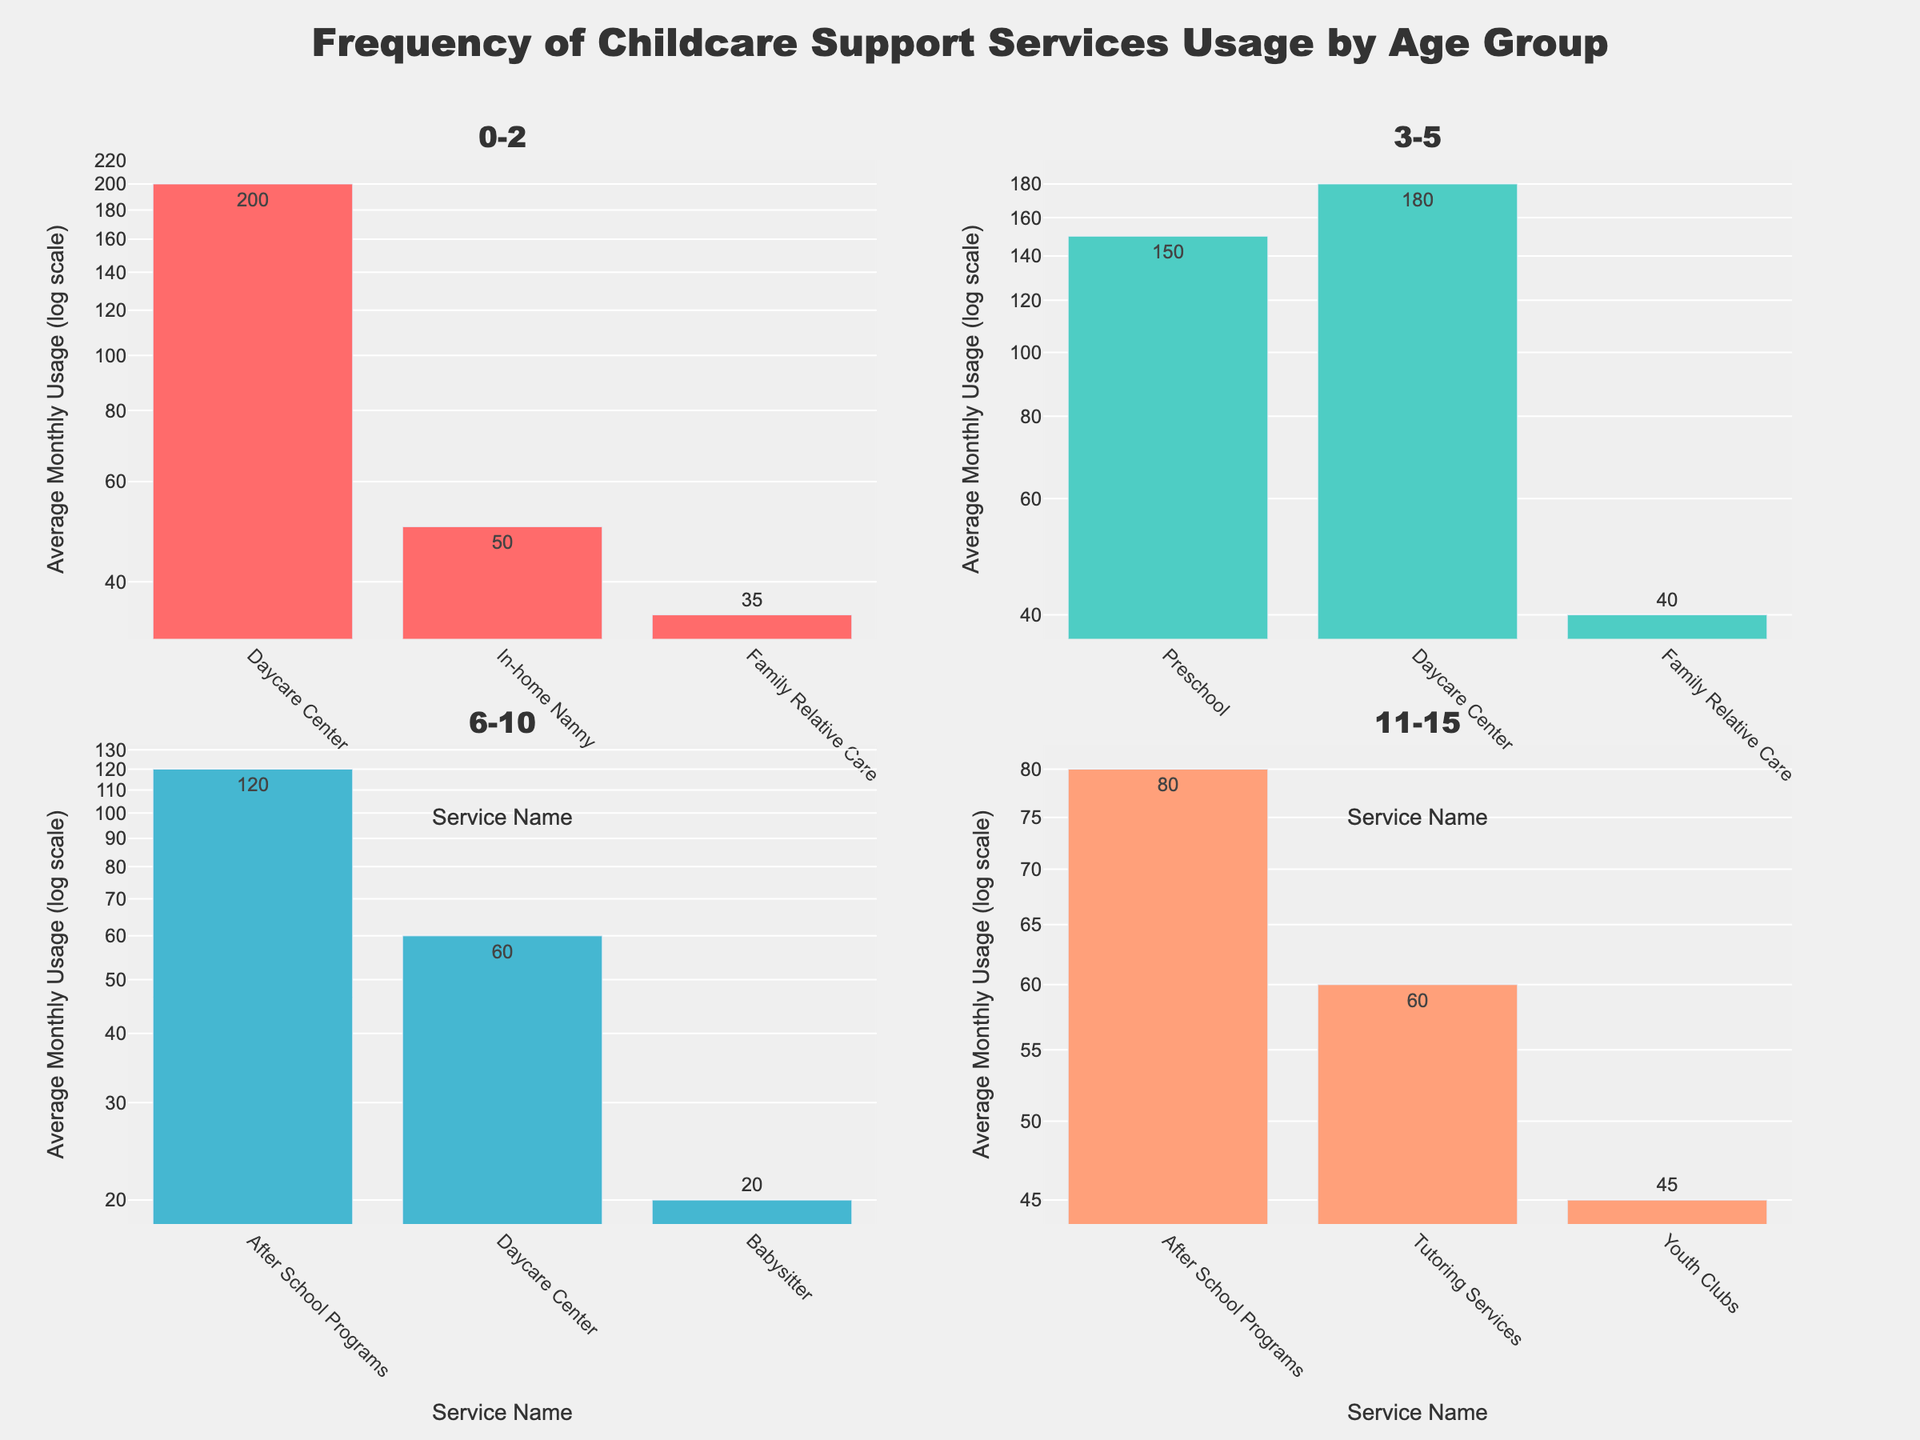Which age group has the highest average monthly usage for Daycare Center? By looking at the bar for Daycare Center in each subplot, the tallest bar appears in the 0-2 age group.
Answer: 0-2 Which childcare service has the lowest average monthly usage in the 6-10 age group? By observing the bars in the 6-10 age group subplot, the shortest bar is Babysitter.
Answer: Babysitter What is the combined average monthly usage for Family Relative Care across both the age groups it appears in? Family Relative Care usage appears in the 0-2 (35) and 3-5 (40) age groups. Adding them up: 35 + 40 = 75.
Answer: 75 How does the average monthly usage of Tutoring Services in the 11-15 age group compare to Babysitter in the 6-10 age group? Tutoring Services has an average monthly usage of 60, while Babysitter has 20. 60 is greater than 20.
Answer: Tutoring Services is higher Are there any age groups where none of the childcare services have an average monthly usage below 40? By examining each subplot, only the 3-5 age group has no bars below the usage of 40 in the log scale.
Answer: 3-5 What is the difference in average monthly usage between After School Programs and the second most used service in the 6-10 age group? In the 6-10 group, After School Programs (120) and Daycare Center (60). Subtracting: 120 - 60 = 60.
Answer: 60 Which age group uses Preschool services, and what is its average monthly usage? Only the 3-5 age group uses Preschool, with an average monthly usage of 150.
Answer: 3-5, 150 How many different types of childcare services are used by the 0-2 age group? By counting the unique bars in the 0-2 subplot, there are 3 services (Daycare Center, In-home Nanny, Family Relative Care).
Answer: 3 What is the most frequently used childcare service in the 11-15 age group? Examining the tallest bar in the 11-15 subplot, After School Programs has the highest usage of 80.
Answer: After School Programs 